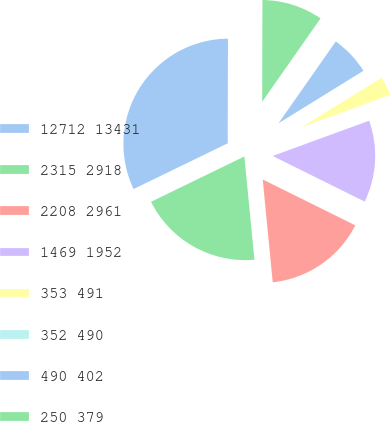Convert chart to OTSL. <chart><loc_0><loc_0><loc_500><loc_500><pie_chart><fcel>12712 13431<fcel>2315 2918<fcel>2208 2961<fcel>1469 1952<fcel>353 491<fcel>352 490<fcel>490 402<fcel>250 379<nl><fcel>32.24%<fcel>19.35%<fcel>16.13%<fcel>12.9%<fcel>3.23%<fcel>0.01%<fcel>6.46%<fcel>9.68%<nl></chart> 